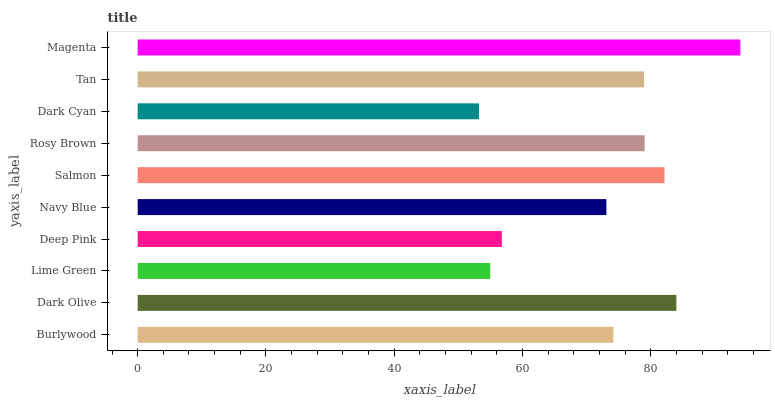Is Dark Cyan the minimum?
Answer yes or no. Yes. Is Magenta the maximum?
Answer yes or no. Yes. Is Dark Olive the minimum?
Answer yes or no. No. Is Dark Olive the maximum?
Answer yes or no. No. Is Dark Olive greater than Burlywood?
Answer yes or no. Yes. Is Burlywood less than Dark Olive?
Answer yes or no. Yes. Is Burlywood greater than Dark Olive?
Answer yes or no. No. Is Dark Olive less than Burlywood?
Answer yes or no. No. Is Tan the high median?
Answer yes or no. Yes. Is Burlywood the low median?
Answer yes or no. Yes. Is Rosy Brown the high median?
Answer yes or no. No. Is Deep Pink the low median?
Answer yes or no. No. 